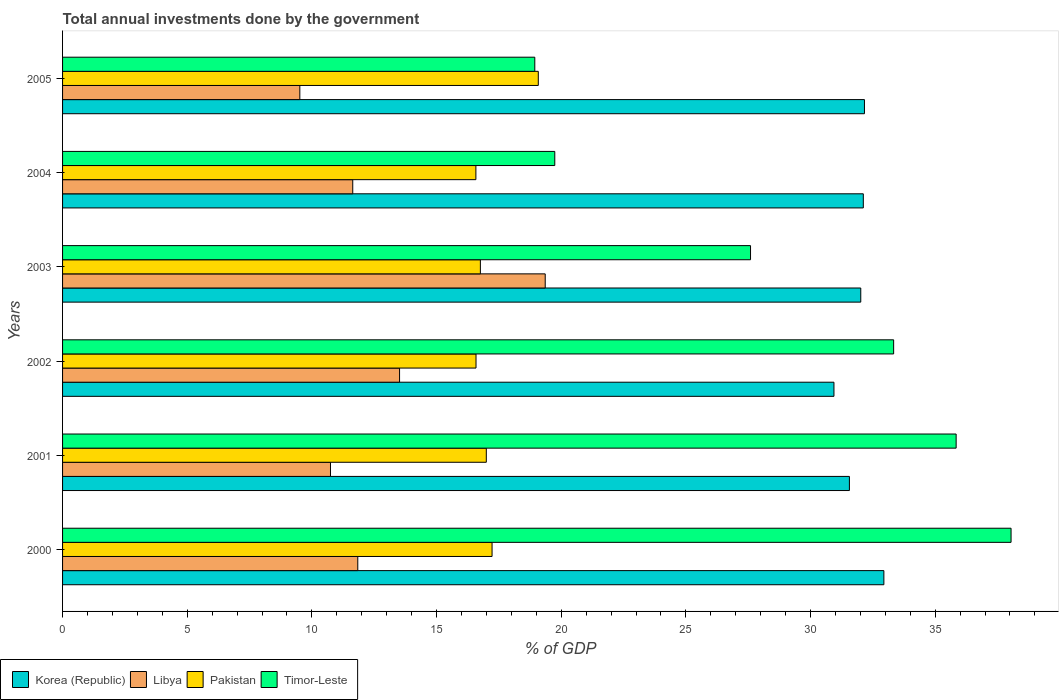How many different coloured bars are there?
Ensure brevity in your answer.  4. Are the number of bars per tick equal to the number of legend labels?
Provide a succinct answer. Yes. Are the number of bars on each tick of the Y-axis equal?
Provide a short and direct response. Yes. How many bars are there on the 2nd tick from the bottom?
Your response must be concise. 4. What is the total annual investments done by the government in Pakistan in 2003?
Provide a succinct answer. 16.76. Across all years, what is the maximum total annual investments done by the government in Pakistan?
Offer a very short reply. 19.08. Across all years, what is the minimum total annual investments done by the government in Korea (Republic)?
Your answer should be compact. 30.94. In which year was the total annual investments done by the government in Libya maximum?
Your answer should be compact. 2003. What is the total total annual investments done by the government in Timor-Leste in the graph?
Give a very brief answer. 173.49. What is the difference between the total annual investments done by the government in Korea (Republic) in 2000 and that in 2003?
Your answer should be compact. 0.93. What is the difference between the total annual investments done by the government in Timor-Leste in 2004 and the total annual investments done by the government in Pakistan in 2005?
Offer a terse response. 0.66. What is the average total annual investments done by the government in Korea (Republic) per year?
Give a very brief answer. 31.96. In the year 2000, what is the difference between the total annual investments done by the government in Pakistan and total annual investments done by the government in Timor-Leste?
Give a very brief answer. -20.82. In how many years, is the total annual investments done by the government in Timor-Leste greater than 21 %?
Your response must be concise. 4. What is the ratio of the total annual investments done by the government in Libya in 2002 to that in 2004?
Offer a terse response. 1.16. Is the total annual investments done by the government in Libya in 2002 less than that in 2005?
Keep it short and to the point. No. What is the difference between the highest and the second highest total annual investments done by the government in Pakistan?
Ensure brevity in your answer.  1.85. What is the difference between the highest and the lowest total annual investments done by the government in Libya?
Provide a succinct answer. 9.84. Is the sum of the total annual investments done by the government in Korea (Republic) in 2002 and 2005 greater than the maximum total annual investments done by the government in Timor-Leste across all years?
Provide a succinct answer. Yes. Is it the case that in every year, the sum of the total annual investments done by the government in Libya and total annual investments done by the government in Timor-Leste is greater than the sum of total annual investments done by the government in Pakistan and total annual investments done by the government in Korea (Republic)?
Offer a terse response. No. What does the 1st bar from the bottom in 2000 represents?
Give a very brief answer. Korea (Republic). Are all the bars in the graph horizontal?
Your answer should be very brief. Yes. How many years are there in the graph?
Provide a short and direct response. 6. What is the difference between two consecutive major ticks on the X-axis?
Offer a very short reply. 5. Are the values on the major ticks of X-axis written in scientific E-notation?
Your answer should be compact. No. Does the graph contain grids?
Provide a short and direct response. No. How are the legend labels stacked?
Ensure brevity in your answer.  Horizontal. What is the title of the graph?
Keep it short and to the point. Total annual investments done by the government. Does "Philippines" appear as one of the legend labels in the graph?
Give a very brief answer. No. What is the label or title of the X-axis?
Give a very brief answer. % of GDP. What is the label or title of the Y-axis?
Offer a very short reply. Years. What is the % of GDP of Korea (Republic) in 2000?
Provide a short and direct response. 32.94. What is the % of GDP in Libya in 2000?
Give a very brief answer. 11.84. What is the % of GDP in Pakistan in 2000?
Provide a short and direct response. 17.23. What is the % of GDP of Timor-Leste in 2000?
Your response must be concise. 38.04. What is the % of GDP in Korea (Republic) in 2001?
Provide a short and direct response. 31.56. What is the % of GDP in Libya in 2001?
Offer a very short reply. 10.75. What is the % of GDP of Pakistan in 2001?
Offer a very short reply. 17. What is the % of GDP of Timor-Leste in 2001?
Make the answer very short. 35.84. What is the % of GDP of Korea (Republic) in 2002?
Keep it short and to the point. 30.94. What is the % of GDP of Libya in 2002?
Make the answer very short. 13.52. What is the % of GDP of Pakistan in 2002?
Offer a very short reply. 16.58. What is the % of GDP in Timor-Leste in 2002?
Give a very brief answer. 33.33. What is the % of GDP of Korea (Republic) in 2003?
Make the answer very short. 32.01. What is the % of GDP in Libya in 2003?
Ensure brevity in your answer.  19.36. What is the % of GDP in Pakistan in 2003?
Offer a very short reply. 16.76. What is the % of GDP in Timor-Leste in 2003?
Ensure brevity in your answer.  27.59. What is the % of GDP in Korea (Republic) in 2004?
Make the answer very short. 32.12. What is the % of GDP of Libya in 2004?
Give a very brief answer. 11.64. What is the % of GDP in Pakistan in 2004?
Your answer should be compact. 16.58. What is the % of GDP of Timor-Leste in 2004?
Your answer should be compact. 19.74. What is the % of GDP in Korea (Republic) in 2005?
Provide a succinct answer. 32.16. What is the % of GDP of Libya in 2005?
Keep it short and to the point. 9.52. What is the % of GDP of Pakistan in 2005?
Keep it short and to the point. 19.08. What is the % of GDP in Timor-Leste in 2005?
Ensure brevity in your answer.  18.94. Across all years, what is the maximum % of GDP of Korea (Republic)?
Offer a very short reply. 32.94. Across all years, what is the maximum % of GDP of Libya?
Your answer should be compact. 19.36. Across all years, what is the maximum % of GDP in Pakistan?
Your answer should be very brief. 19.08. Across all years, what is the maximum % of GDP in Timor-Leste?
Your answer should be compact. 38.04. Across all years, what is the minimum % of GDP of Korea (Republic)?
Make the answer very short. 30.94. Across all years, what is the minimum % of GDP of Libya?
Your answer should be very brief. 9.52. Across all years, what is the minimum % of GDP of Pakistan?
Your answer should be very brief. 16.58. Across all years, what is the minimum % of GDP of Timor-Leste?
Keep it short and to the point. 18.94. What is the total % of GDP of Korea (Republic) in the graph?
Your answer should be very brief. 191.74. What is the total % of GDP in Libya in the graph?
Give a very brief answer. 76.62. What is the total % of GDP of Pakistan in the graph?
Provide a succinct answer. 103.22. What is the total % of GDP in Timor-Leste in the graph?
Provide a succinct answer. 173.49. What is the difference between the % of GDP in Korea (Republic) in 2000 and that in 2001?
Your response must be concise. 1.38. What is the difference between the % of GDP in Libya in 2000 and that in 2001?
Give a very brief answer. 1.09. What is the difference between the % of GDP of Pakistan in 2000 and that in 2001?
Keep it short and to the point. 0.23. What is the difference between the % of GDP of Timor-Leste in 2000 and that in 2001?
Ensure brevity in your answer.  2.2. What is the difference between the % of GDP of Korea (Republic) in 2000 and that in 2002?
Give a very brief answer. 2. What is the difference between the % of GDP of Libya in 2000 and that in 2002?
Provide a short and direct response. -1.68. What is the difference between the % of GDP of Pakistan in 2000 and that in 2002?
Provide a short and direct response. 0.64. What is the difference between the % of GDP in Timor-Leste in 2000 and that in 2002?
Your answer should be compact. 4.71. What is the difference between the % of GDP in Korea (Republic) in 2000 and that in 2003?
Your response must be concise. 0.93. What is the difference between the % of GDP in Libya in 2000 and that in 2003?
Offer a very short reply. -7.52. What is the difference between the % of GDP in Pakistan in 2000 and that in 2003?
Offer a terse response. 0.47. What is the difference between the % of GDP of Timor-Leste in 2000 and that in 2003?
Provide a succinct answer. 10.45. What is the difference between the % of GDP of Korea (Republic) in 2000 and that in 2004?
Offer a terse response. 0.82. What is the difference between the % of GDP in Libya in 2000 and that in 2004?
Your answer should be very brief. 0.2. What is the difference between the % of GDP in Pakistan in 2000 and that in 2004?
Offer a terse response. 0.65. What is the difference between the % of GDP in Timor-Leste in 2000 and that in 2004?
Offer a terse response. 18.3. What is the difference between the % of GDP in Korea (Republic) in 2000 and that in 2005?
Offer a very short reply. 0.78. What is the difference between the % of GDP in Libya in 2000 and that in 2005?
Keep it short and to the point. 2.32. What is the difference between the % of GDP in Pakistan in 2000 and that in 2005?
Make the answer very short. -1.85. What is the difference between the % of GDP of Timor-Leste in 2000 and that in 2005?
Ensure brevity in your answer.  19.1. What is the difference between the % of GDP of Korea (Republic) in 2001 and that in 2002?
Provide a short and direct response. 0.62. What is the difference between the % of GDP of Libya in 2001 and that in 2002?
Ensure brevity in your answer.  -2.77. What is the difference between the % of GDP in Pakistan in 2001 and that in 2002?
Provide a short and direct response. 0.41. What is the difference between the % of GDP of Timor-Leste in 2001 and that in 2002?
Provide a succinct answer. 2.51. What is the difference between the % of GDP of Korea (Republic) in 2001 and that in 2003?
Keep it short and to the point. -0.46. What is the difference between the % of GDP in Libya in 2001 and that in 2003?
Give a very brief answer. -8.61. What is the difference between the % of GDP in Pakistan in 2001 and that in 2003?
Your response must be concise. 0.24. What is the difference between the % of GDP of Timor-Leste in 2001 and that in 2003?
Your response must be concise. 8.25. What is the difference between the % of GDP in Korea (Republic) in 2001 and that in 2004?
Offer a terse response. -0.56. What is the difference between the % of GDP in Libya in 2001 and that in 2004?
Your response must be concise. -0.89. What is the difference between the % of GDP in Pakistan in 2001 and that in 2004?
Make the answer very short. 0.42. What is the difference between the % of GDP in Timor-Leste in 2001 and that in 2004?
Your answer should be very brief. 16.1. What is the difference between the % of GDP of Korea (Republic) in 2001 and that in 2005?
Your answer should be compact. -0.6. What is the difference between the % of GDP of Libya in 2001 and that in 2005?
Ensure brevity in your answer.  1.23. What is the difference between the % of GDP in Pakistan in 2001 and that in 2005?
Offer a terse response. -2.08. What is the difference between the % of GDP of Timor-Leste in 2001 and that in 2005?
Keep it short and to the point. 16.9. What is the difference between the % of GDP of Korea (Republic) in 2002 and that in 2003?
Keep it short and to the point. -1.08. What is the difference between the % of GDP of Libya in 2002 and that in 2003?
Your answer should be compact. -5.84. What is the difference between the % of GDP in Pakistan in 2002 and that in 2003?
Ensure brevity in your answer.  -0.18. What is the difference between the % of GDP of Timor-Leste in 2002 and that in 2003?
Make the answer very short. 5.74. What is the difference between the % of GDP of Korea (Republic) in 2002 and that in 2004?
Ensure brevity in your answer.  -1.18. What is the difference between the % of GDP of Libya in 2002 and that in 2004?
Make the answer very short. 1.88. What is the difference between the % of GDP in Pakistan in 2002 and that in 2004?
Provide a succinct answer. 0. What is the difference between the % of GDP of Timor-Leste in 2002 and that in 2004?
Make the answer very short. 13.59. What is the difference between the % of GDP in Korea (Republic) in 2002 and that in 2005?
Keep it short and to the point. -1.22. What is the difference between the % of GDP in Libya in 2002 and that in 2005?
Your answer should be very brief. 4. What is the difference between the % of GDP in Pakistan in 2002 and that in 2005?
Offer a very short reply. -2.5. What is the difference between the % of GDP in Timor-Leste in 2002 and that in 2005?
Give a very brief answer. 14.39. What is the difference between the % of GDP in Korea (Republic) in 2003 and that in 2004?
Your response must be concise. -0.1. What is the difference between the % of GDP in Libya in 2003 and that in 2004?
Ensure brevity in your answer.  7.72. What is the difference between the % of GDP in Pakistan in 2003 and that in 2004?
Offer a very short reply. 0.18. What is the difference between the % of GDP of Timor-Leste in 2003 and that in 2004?
Make the answer very short. 7.85. What is the difference between the % of GDP of Korea (Republic) in 2003 and that in 2005?
Offer a terse response. -0.15. What is the difference between the % of GDP in Libya in 2003 and that in 2005?
Make the answer very short. 9.84. What is the difference between the % of GDP in Pakistan in 2003 and that in 2005?
Your answer should be very brief. -2.32. What is the difference between the % of GDP of Timor-Leste in 2003 and that in 2005?
Offer a terse response. 8.65. What is the difference between the % of GDP of Korea (Republic) in 2004 and that in 2005?
Your answer should be compact. -0.05. What is the difference between the % of GDP of Libya in 2004 and that in 2005?
Offer a terse response. 2.12. What is the difference between the % of GDP in Pakistan in 2004 and that in 2005?
Offer a terse response. -2.5. What is the difference between the % of GDP in Timor-Leste in 2004 and that in 2005?
Your answer should be compact. 0.8. What is the difference between the % of GDP in Korea (Republic) in 2000 and the % of GDP in Libya in 2001?
Offer a terse response. 22.2. What is the difference between the % of GDP of Korea (Republic) in 2000 and the % of GDP of Pakistan in 2001?
Keep it short and to the point. 15.95. What is the difference between the % of GDP of Korea (Republic) in 2000 and the % of GDP of Timor-Leste in 2001?
Offer a very short reply. -2.9. What is the difference between the % of GDP of Libya in 2000 and the % of GDP of Pakistan in 2001?
Give a very brief answer. -5.16. What is the difference between the % of GDP in Libya in 2000 and the % of GDP in Timor-Leste in 2001?
Make the answer very short. -24. What is the difference between the % of GDP in Pakistan in 2000 and the % of GDP in Timor-Leste in 2001?
Provide a succinct answer. -18.61. What is the difference between the % of GDP in Korea (Republic) in 2000 and the % of GDP in Libya in 2002?
Your answer should be very brief. 19.42. What is the difference between the % of GDP in Korea (Republic) in 2000 and the % of GDP in Pakistan in 2002?
Keep it short and to the point. 16.36. What is the difference between the % of GDP of Korea (Republic) in 2000 and the % of GDP of Timor-Leste in 2002?
Offer a very short reply. -0.39. What is the difference between the % of GDP of Libya in 2000 and the % of GDP of Pakistan in 2002?
Make the answer very short. -4.74. What is the difference between the % of GDP of Libya in 2000 and the % of GDP of Timor-Leste in 2002?
Provide a succinct answer. -21.49. What is the difference between the % of GDP in Pakistan in 2000 and the % of GDP in Timor-Leste in 2002?
Offer a terse response. -16.11. What is the difference between the % of GDP in Korea (Republic) in 2000 and the % of GDP in Libya in 2003?
Keep it short and to the point. 13.58. What is the difference between the % of GDP in Korea (Republic) in 2000 and the % of GDP in Pakistan in 2003?
Your answer should be compact. 16.18. What is the difference between the % of GDP in Korea (Republic) in 2000 and the % of GDP in Timor-Leste in 2003?
Keep it short and to the point. 5.35. What is the difference between the % of GDP of Libya in 2000 and the % of GDP of Pakistan in 2003?
Give a very brief answer. -4.92. What is the difference between the % of GDP in Libya in 2000 and the % of GDP in Timor-Leste in 2003?
Offer a very short reply. -15.75. What is the difference between the % of GDP in Pakistan in 2000 and the % of GDP in Timor-Leste in 2003?
Ensure brevity in your answer.  -10.37. What is the difference between the % of GDP of Korea (Republic) in 2000 and the % of GDP of Libya in 2004?
Your answer should be very brief. 21.3. What is the difference between the % of GDP in Korea (Republic) in 2000 and the % of GDP in Pakistan in 2004?
Provide a succinct answer. 16.36. What is the difference between the % of GDP of Korea (Republic) in 2000 and the % of GDP of Timor-Leste in 2004?
Keep it short and to the point. 13.2. What is the difference between the % of GDP in Libya in 2000 and the % of GDP in Pakistan in 2004?
Provide a short and direct response. -4.74. What is the difference between the % of GDP in Libya in 2000 and the % of GDP in Timor-Leste in 2004?
Your answer should be compact. -7.9. What is the difference between the % of GDP of Pakistan in 2000 and the % of GDP of Timor-Leste in 2004?
Your response must be concise. -2.52. What is the difference between the % of GDP of Korea (Republic) in 2000 and the % of GDP of Libya in 2005?
Keep it short and to the point. 23.43. What is the difference between the % of GDP of Korea (Republic) in 2000 and the % of GDP of Pakistan in 2005?
Provide a succinct answer. 13.86. What is the difference between the % of GDP in Korea (Republic) in 2000 and the % of GDP in Timor-Leste in 2005?
Keep it short and to the point. 14. What is the difference between the % of GDP in Libya in 2000 and the % of GDP in Pakistan in 2005?
Provide a succinct answer. -7.24. What is the difference between the % of GDP in Libya in 2000 and the % of GDP in Timor-Leste in 2005?
Ensure brevity in your answer.  -7.1. What is the difference between the % of GDP in Pakistan in 2000 and the % of GDP in Timor-Leste in 2005?
Keep it short and to the point. -1.71. What is the difference between the % of GDP of Korea (Republic) in 2001 and the % of GDP of Libya in 2002?
Your answer should be compact. 18.04. What is the difference between the % of GDP in Korea (Republic) in 2001 and the % of GDP in Pakistan in 2002?
Your answer should be very brief. 14.98. What is the difference between the % of GDP of Korea (Republic) in 2001 and the % of GDP of Timor-Leste in 2002?
Your response must be concise. -1.77. What is the difference between the % of GDP of Libya in 2001 and the % of GDP of Pakistan in 2002?
Make the answer very short. -5.84. What is the difference between the % of GDP in Libya in 2001 and the % of GDP in Timor-Leste in 2002?
Give a very brief answer. -22.59. What is the difference between the % of GDP in Pakistan in 2001 and the % of GDP in Timor-Leste in 2002?
Your response must be concise. -16.34. What is the difference between the % of GDP in Korea (Republic) in 2001 and the % of GDP in Libya in 2003?
Make the answer very short. 12.2. What is the difference between the % of GDP of Korea (Republic) in 2001 and the % of GDP of Pakistan in 2003?
Offer a terse response. 14.8. What is the difference between the % of GDP of Korea (Republic) in 2001 and the % of GDP of Timor-Leste in 2003?
Offer a terse response. 3.97. What is the difference between the % of GDP in Libya in 2001 and the % of GDP in Pakistan in 2003?
Give a very brief answer. -6.01. What is the difference between the % of GDP of Libya in 2001 and the % of GDP of Timor-Leste in 2003?
Your response must be concise. -16.85. What is the difference between the % of GDP of Pakistan in 2001 and the % of GDP of Timor-Leste in 2003?
Your response must be concise. -10.6. What is the difference between the % of GDP in Korea (Republic) in 2001 and the % of GDP in Libya in 2004?
Provide a short and direct response. 19.92. What is the difference between the % of GDP in Korea (Republic) in 2001 and the % of GDP in Pakistan in 2004?
Ensure brevity in your answer.  14.98. What is the difference between the % of GDP in Korea (Republic) in 2001 and the % of GDP in Timor-Leste in 2004?
Your response must be concise. 11.82. What is the difference between the % of GDP in Libya in 2001 and the % of GDP in Pakistan in 2004?
Keep it short and to the point. -5.83. What is the difference between the % of GDP of Libya in 2001 and the % of GDP of Timor-Leste in 2004?
Keep it short and to the point. -9. What is the difference between the % of GDP in Pakistan in 2001 and the % of GDP in Timor-Leste in 2004?
Keep it short and to the point. -2.75. What is the difference between the % of GDP of Korea (Republic) in 2001 and the % of GDP of Libya in 2005?
Your response must be concise. 22.04. What is the difference between the % of GDP of Korea (Republic) in 2001 and the % of GDP of Pakistan in 2005?
Your answer should be very brief. 12.48. What is the difference between the % of GDP in Korea (Republic) in 2001 and the % of GDP in Timor-Leste in 2005?
Provide a short and direct response. 12.62. What is the difference between the % of GDP of Libya in 2001 and the % of GDP of Pakistan in 2005?
Your answer should be very brief. -8.34. What is the difference between the % of GDP of Libya in 2001 and the % of GDP of Timor-Leste in 2005?
Ensure brevity in your answer.  -8.19. What is the difference between the % of GDP in Pakistan in 2001 and the % of GDP in Timor-Leste in 2005?
Offer a very short reply. -1.94. What is the difference between the % of GDP of Korea (Republic) in 2002 and the % of GDP of Libya in 2003?
Your response must be concise. 11.58. What is the difference between the % of GDP of Korea (Republic) in 2002 and the % of GDP of Pakistan in 2003?
Give a very brief answer. 14.18. What is the difference between the % of GDP in Korea (Republic) in 2002 and the % of GDP in Timor-Leste in 2003?
Your answer should be very brief. 3.35. What is the difference between the % of GDP of Libya in 2002 and the % of GDP of Pakistan in 2003?
Give a very brief answer. -3.24. What is the difference between the % of GDP of Libya in 2002 and the % of GDP of Timor-Leste in 2003?
Provide a short and direct response. -14.08. What is the difference between the % of GDP in Pakistan in 2002 and the % of GDP in Timor-Leste in 2003?
Offer a very short reply. -11.01. What is the difference between the % of GDP in Korea (Republic) in 2002 and the % of GDP in Libya in 2004?
Make the answer very short. 19.3. What is the difference between the % of GDP of Korea (Republic) in 2002 and the % of GDP of Pakistan in 2004?
Provide a succinct answer. 14.36. What is the difference between the % of GDP of Korea (Republic) in 2002 and the % of GDP of Timor-Leste in 2004?
Your response must be concise. 11.2. What is the difference between the % of GDP of Libya in 2002 and the % of GDP of Pakistan in 2004?
Make the answer very short. -3.06. What is the difference between the % of GDP of Libya in 2002 and the % of GDP of Timor-Leste in 2004?
Ensure brevity in your answer.  -6.23. What is the difference between the % of GDP of Pakistan in 2002 and the % of GDP of Timor-Leste in 2004?
Provide a short and direct response. -3.16. What is the difference between the % of GDP in Korea (Republic) in 2002 and the % of GDP in Libya in 2005?
Provide a succinct answer. 21.42. What is the difference between the % of GDP of Korea (Republic) in 2002 and the % of GDP of Pakistan in 2005?
Offer a terse response. 11.86. What is the difference between the % of GDP of Korea (Republic) in 2002 and the % of GDP of Timor-Leste in 2005?
Give a very brief answer. 12. What is the difference between the % of GDP in Libya in 2002 and the % of GDP in Pakistan in 2005?
Ensure brevity in your answer.  -5.56. What is the difference between the % of GDP in Libya in 2002 and the % of GDP in Timor-Leste in 2005?
Provide a succinct answer. -5.42. What is the difference between the % of GDP of Pakistan in 2002 and the % of GDP of Timor-Leste in 2005?
Your response must be concise. -2.36. What is the difference between the % of GDP in Korea (Republic) in 2003 and the % of GDP in Libya in 2004?
Provide a short and direct response. 20.38. What is the difference between the % of GDP of Korea (Republic) in 2003 and the % of GDP of Pakistan in 2004?
Your response must be concise. 15.44. What is the difference between the % of GDP in Korea (Republic) in 2003 and the % of GDP in Timor-Leste in 2004?
Ensure brevity in your answer.  12.27. What is the difference between the % of GDP in Libya in 2003 and the % of GDP in Pakistan in 2004?
Offer a very short reply. 2.78. What is the difference between the % of GDP in Libya in 2003 and the % of GDP in Timor-Leste in 2004?
Make the answer very short. -0.38. What is the difference between the % of GDP of Pakistan in 2003 and the % of GDP of Timor-Leste in 2004?
Your answer should be compact. -2.98. What is the difference between the % of GDP in Korea (Republic) in 2003 and the % of GDP in Libya in 2005?
Offer a very short reply. 22.5. What is the difference between the % of GDP of Korea (Republic) in 2003 and the % of GDP of Pakistan in 2005?
Make the answer very short. 12.93. What is the difference between the % of GDP in Korea (Republic) in 2003 and the % of GDP in Timor-Leste in 2005?
Make the answer very short. 13.07. What is the difference between the % of GDP in Libya in 2003 and the % of GDP in Pakistan in 2005?
Provide a short and direct response. 0.28. What is the difference between the % of GDP in Libya in 2003 and the % of GDP in Timor-Leste in 2005?
Your answer should be very brief. 0.42. What is the difference between the % of GDP in Pakistan in 2003 and the % of GDP in Timor-Leste in 2005?
Your answer should be compact. -2.18. What is the difference between the % of GDP in Korea (Republic) in 2004 and the % of GDP in Libya in 2005?
Your answer should be compact. 22.6. What is the difference between the % of GDP of Korea (Republic) in 2004 and the % of GDP of Pakistan in 2005?
Give a very brief answer. 13.04. What is the difference between the % of GDP of Korea (Republic) in 2004 and the % of GDP of Timor-Leste in 2005?
Your answer should be compact. 13.18. What is the difference between the % of GDP of Libya in 2004 and the % of GDP of Pakistan in 2005?
Make the answer very short. -7.44. What is the difference between the % of GDP in Libya in 2004 and the % of GDP in Timor-Leste in 2005?
Ensure brevity in your answer.  -7.3. What is the difference between the % of GDP of Pakistan in 2004 and the % of GDP of Timor-Leste in 2005?
Make the answer very short. -2.36. What is the average % of GDP of Korea (Republic) per year?
Your response must be concise. 31.96. What is the average % of GDP of Libya per year?
Ensure brevity in your answer.  12.77. What is the average % of GDP of Pakistan per year?
Give a very brief answer. 17.2. What is the average % of GDP in Timor-Leste per year?
Your response must be concise. 28.92. In the year 2000, what is the difference between the % of GDP in Korea (Republic) and % of GDP in Libya?
Keep it short and to the point. 21.1. In the year 2000, what is the difference between the % of GDP in Korea (Republic) and % of GDP in Pakistan?
Keep it short and to the point. 15.72. In the year 2000, what is the difference between the % of GDP of Korea (Republic) and % of GDP of Timor-Leste?
Offer a very short reply. -5.1. In the year 2000, what is the difference between the % of GDP in Libya and % of GDP in Pakistan?
Your response must be concise. -5.39. In the year 2000, what is the difference between the % of GDP in Libya and % of GDP in Timor-Leste?
Your answer should be compact. -26.2. In the year 2000, what is the difference between the % of GDP of Pakistan and % of GDP of Timor-Leste?
Your answer should be compact. -20.82. In the year 2001, what is the difference between the % of GDP of Korea (Republic) and % of GDP of Libya?
Offer a terse response. 20.81. In the year 2001, what is the difference between the % of GDP in Korea (Republic) and % of GDP in Pakistan?
Your answer should be very brief. 14.56. In the year 2001, what is the difference between the % of GDP in Korea (Republic) and % of GDP in Timor-Leste?
Make the answer very short. -4.28. In the year 2001, what is the difference between the % of GDP of Libya and % of GDP of Pakistan?
Provide a succinct answer. -6.25. In the year 2001, what is the difference between the % of GDP of Libya and % of GDP of Timor-Leste?
Make the answer very short. -25.09. In the year 2001, what is the difference between the % of GDP of Pakistan and % of GDP of Timor-Leste?
Offer a terse response. -18.84. In the year 2002, what is the difference between the % of GDP in Korea (Republic) and % of GDP in Libya?
Offer a terse response. 17.42. In the year 2002, what is the difference between the % of GDP in Korea (Republic) and % of GDP in Pakistan?
Keep it short and to the point. 14.36. In the year 2002, what is the difference between the % of GDP in Korea (Republic) and % of GDP in Timor-Leste?
Your response must be concise. -2.39. In the year 2002, what is the difference between the % of GDP in Libya and % of GDP in Pakistan?
Offer a terse response. -3.07. In the year 2002, what is the difference between the % of GDP in Libya and % of GDP in Timor-Leste?
Your response must be concise. -19.82. In the year 2002, what is the difference between the % of GDP in Pakistan and % of GDP in Timor-Leste?
Provide a short and direct response. -16.75. In the year 2003, what is the difference between the % of GDP of Korea (Republic) and % of GDP of Libya?
Make the answer very short. 12.66. In the year 2003, what is the difference between the % of GDP in Korea (Republic) and % of GDP in Pakistan?
Keep it short and to the point. 15.26. In the year 2003, what is the difference between the % of GDP of Korea (Republic) and % of GDP of Timor-Leste?
Provide a short and direct response. 4.42. In the year 2003, what is the difference between the % of GDP in Libya and % of GDP in Pakistan?
Keep it short and to the point. 2.6. In the year 2003, what is the difference between the % of GDP in Libya and % of GDP in Timor-Leste?
Provide a short and direct response. -8.23. In the year 2003, what is the difference between the % of GDP in Pakistan and % of GDP in Timor-Leste?
Make the answer very short. -10.84. In the year 2004, what is the difference between the % of GDP in Korea (Republic) and % of GDP in Libya?
Ensure brevity in your answer.  20.48. In the year 2004, what is the difference between the % of GDP of Korea (Republic) and % of GDP of Pakistan?
Keep it short and to the point. 15.54. In the year 2004, what is the difference between the % of GDP in Korea (Republic) and % of GDP in Timor-Leste?
Offer a terse response. 12.37. In the year 2004, what is the difference between the % of GDP of Libya and % of GDP of Pakistan?
Keep it short and to the point. -4.94. In the year 2004, what is the difference between the % of GDP of Libya and % of GDP of Timor-Leste?
Offer a terse response. -8.1. In the year 2004, what is the difference between the % of GDP of Pakistan and % of GDP of Timor-Leste?
Keep it short and to the point. -3.16. In the year 2005, what is the difference between the % of GDP of Korea (Republic) and % of GDP of Libya?
Provide a succinct answer. 22.65. In the year 2005, what is the difference between the % of GDP of Korea (Republic) and % of GDP of Pakistan?
Provide a short and direct response. 13.08. In the year 2005, what is the difference between the % of GDP of Korea (Republic) and % of GDP of Timor-Leste?
Give a very brief answer. 13.22. In the year 2005, what is the difference between the % of GDP in Libya and % of GDP in Pakistan?
Provide a succinct answer. -9.56. In the year 2005, what is the difference between the % of GDP in Libya and % of GDP in Timor-Leste?
Make the answer very short. -9.42. In the year 2005, what is the difference between the % of GDP of Pakistan and % of GDP of Timor-Leste?
Make the answer very short. 0.14. What is the ratio of the % of GDP of Korea (Republic) in 2000 to that in 2001?
Your answer should be compact. 1.04. What is the ratio of the % of GDP of Libya in 2000 to that in 2001?
Offer a very short reply. 1.1. What is the ratio of the % of GDP in Pakistan in 2000 to that in 2001?
Offer a very short reply. 1.01. What is the ratio of the % of GDP in Timor-Leste in 2000 to that in 2001?
Ensure brevity in your answer.  1.06. What is the ratio of the % of GDP in Korea (Republic) in 2000 to that in 2002?
Ensure brevity in your answer.  1.06. What is the ratio of the % of GDP of Libya in 2000 to that in 2002?
Your response must be concise. 0.88. What is the ratio of the % of GDP in Pakistan in 2000 to that in 2002?
Your answer should be very brief. 1.04. What is the ratio of the % of GDP of Timor-Leste in 2000 to that in 2002?
Provide a short and direct response. 1.14. What is the ratio of the % of GDP in Korea (Republic) in 2000 to that in 2003?
Ensure brevity in your answer.  1.03. What is the ratio of the % of GDP in Libya in 2000 to that in 2003?
Offer a terse response. 0.61. What is the ratio of the % of GDP of Pakistan in 2000 to that in 2003?
Make the answer very short. 1.03. What is the ratio of the % of GDP of Timor-Leste in 2000 to that in 2003?
Offer a terse response. 1.38. What is the ratio of the % of GDP of Korea (Republic) in 2000 to that in 2004?
Your answer should be compact. 1.03. What is the ratio of the % of GDP of Libya in 2000 to that in 2004?
Your response must be concise. 1.02. What is the ratio of the % of GDP of Pakistan in 2000 to that in 2004?
Ensure brevity in your answer.  1.04. What is the ratio of the % of GDP of Timor-Leste in 2000 to that in 2004?
Your answer should be compact. 1.93. What is the ratio of the % of GDP of Korea (Republic) in 2000 to that in 2005?
Your answer should be very brief. 1.02. What is the ratio of the % of GDP of Libya in 2000 to that in 2005?
Provide a short and direct response. 1.24. What is the ratio of the % of GDP in Pakistan in 2000 to that in 2005?
Give a very brief answer. 0.9. What is the ratio of the % of GDP in Timor-Leste in 2000 to that in 2005?
Provide a succinct answer. 2.01. What is the ratio of the % of GDP of Libya in 2001 to that in 2002?
Give a very brief answer. 0.8. What is the ratio of the % of GDP of Pakistan in 2001 to that in 2002?
Offer a very short reply. 1.02. What is the ratio of the % of GDP of Timor-Leste in 2001 to that in 2002?
Make the answer very short. 1.08. What is the ratio of the % of GDP of Korea (Republic) in 2001 to that in 2003?
Keep it short and to the point. 0.99. What is the ratio of the % of GDP in Libya in 2001 to that in 2003?
Keep it short and to the point. 0.56. What is the ratio of the % of GDP in Pakistan in 2001 to that in 2003?
Your answer should be very brief. 1.01. What is the ratio of the % of GDP of Timor-Leste in 2001 to that in 2003?
Offer a terse response. 1.3. What is the ratio of the % of GDP of Korea (Republic) in 2001 to that in 2004?
Give a very brief answer. 0.98. What is the ratio of the % of GDP of Libya in 2001 to that in 2004?
Offer a very short reply. 0.92. What is the ratio of the % of GDP in Pakistan in 2001 to that in 2004?
Keep it short and to the point. 1.03. What is the ratio of the % of GDP in Timor-Leste in 2001 to that in 2004?
Your answer should be compact. 1.82. What is the ratio of the % of GDP of Korea (Republic) in 2001 to that in 2005?
Your response must be concise. 0.98. What is the ratio of the % of GDP of Libya in 2001 to that in 2005?
Make the answer very short. 1.13. What is the ratio of the % of GDP in Pakistan in 2001 to that in 2005?
Offer a terse response. 0.89. What is the ratio of the % of GDP of Timor-Leste in 2001 to that in 2005?
Make the answer very short. 1.89. What is the ratio of the % of GDP in Korea (Republic) in 2002 to that in 2003?
Give a very brief answer. 0.97. What is the ratio of the % of GDP in Libya in 2002 to that in 2003?
Make the answer very short. 0.7. What is the ratio of the % of GDP in Timor-Leste in 2002 to that in 2003?
Your response must be concise. 1.21. What is the ratio of the % of GDP of Korea (Republic) in 2002 to that in 2004?
Your answer should be very brief. 0.96. What is the ratio of the % of GDP of Libya in 2002 to that in 2004?
Make the answer very short. 1.16. What is the ratio of the % of GDP of Timor-Leste in 2002 to that in 2004?
Your answer should be compact. 1.69. What is the ratio of the % of GDP of Korea (Republic) in 2002 to that in 2005?
Provide a succinct answer. 0.96. What is the ratio of the % of GDP in Libya in 2002 to that in 2005?
Offer a very short reply. 1.42. What is the ratio of the % of GDP of Pakistan in 2002 to that in 2005?
Provide a succinct answer. 0.87. What is the ratio of the % of GDP in Timor-Leste in 2002 to that in 2005?
Your answer should be compact. 1.76. What is the ratio of the % of GDP of Korea (Republic) in 2003 to that in 2004?
Offer a very short reply. 1. What is the ratio of the % of GDP of Libya in 2003 to that in 2004?
Your answer should be compact. 1.66. What is the ratio of the % of GDP in Pakistan in 2003 to that in 2004?
Ensure brevity in your answer.  1.01. What is the ratio of the % of GDP in Timor-Leste in 2003 to that in 2004?
Keep it short and to the point. 1.4. What is the ratio of the % of GDP of Korea (Republic) in 2003 to that in 2005?
Offer a terse response. 1. What is the ratio of the % of GDP in Libya in 2003 to that in 2005?
Provide a succinct answer. 2.03. What is the ratio of the % of GDP of Pakistan in 2003 to that in 2005?
Provide a succinct answer. 0.88. What is the ratio of the % of GDP in Timor-Leste in 2003 to that in 2005?
Provide a succinct answer. 1.46. What is the ratio of the % of GDP of Korea (Republic) in 2004 to that in 2005?
Offer a very short reply. 1. What is the ratio of the % of GDP in Libya in 2004 to that in 2005?
Your answer should be compact. 1.22. What is the ratio of the % of GDP in Pakistan in 2004 to that in 2005?
Offer a terse response. 0.87. What is the ratio of the % of GDP in Timor-Leste in 2004 to that in 2005?
Your response must be concise. 1.04. What is the difference between the highest and the second highest % of GDP of Korea (Republic)?
Your response must be concise. 0.78. What is the difference between the highest and the second highest % of GDP of Libya?
Offer a terse response. 5.84. What is the difference between the highest and the second highest % of GDP in Pakistan?
Your response must be concise. 1.85. What is the difference between the highest and the second highest % of GDP of Timor-Leste?
Your answer should be compact. 2.2. What is the difference between the highest and the lowest % of GDP in Korea (Republic)?
Your answer should be compact. 2. What is the difference between the highest and the lowest % of GDP of Libya?
Provide a short and direct response. 9.84. What is the difference between the highest and the lowest % of GDP of Pakistan?
Your answer should be very brief. 2.5. What is the difference between the highest and the lowest % of GDP of Timor-Leste?
Offer a very short reply. 19.1. 